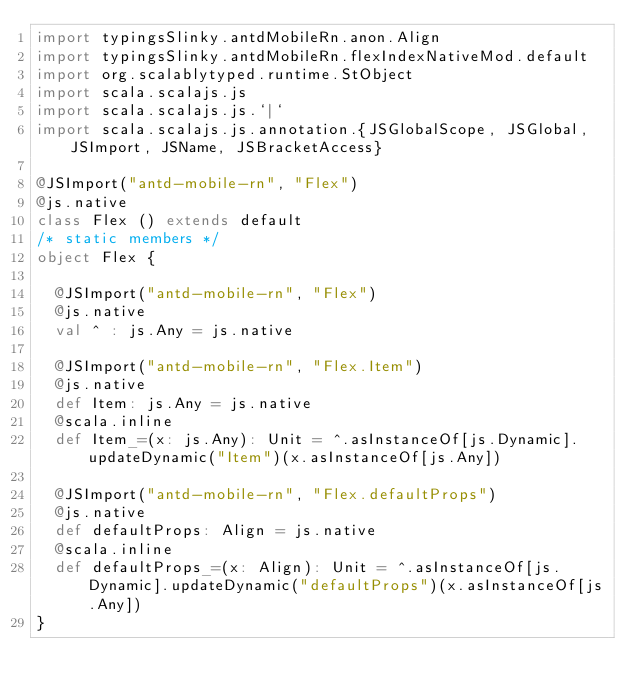Convert code to text. <code><loc_0><loc_0><loc_500><loc_500><_Scala_>import typingsSlinky.antdMobileRn.anon.Align
import typingsSlinky.antdMobileRn.flexIndexNativeMod.default
import org.scalablytyped.runtime.StObject
import scala.scalajs.js
import scala.scalajs.js.`|`
import scala.scalajs.js.annotation.{JSGlobalScope, JSGlobal, JSImport, JSName, JSBracketAccess}

@JSImport("antd-mobile-rn", "Flex")
@js.native
class Flex () extends default
/* static members */
object Flex {
  
  @JSImport("antd-mobile-rn", "Flex")
  @js.native
  val ^ : js.Any = js.native
  
  @JSImport("antd-mobile-rn", "Flex.Item")
  @js.native
  def Item: js.Any = js.native
  @scala.inline
  def Item_=(x: js.Any): Unit = ^.asInstanceOf[js.Dynamic].updateDynamic("Item")(x.asInstanceOf[js.Any])
  
  @JSImport("antd-mobile-rn", "Flex.defaultProps")
  @js.native
  def defaultProps: Align = js.native
  @scala.inline
  def defaultProps_=(x: Align): Unit = ^.asInstanceOf[js.Dynamic].updateDynamic("defaultProps")(x.asInstanceOf[js.Any])
}
</code> 